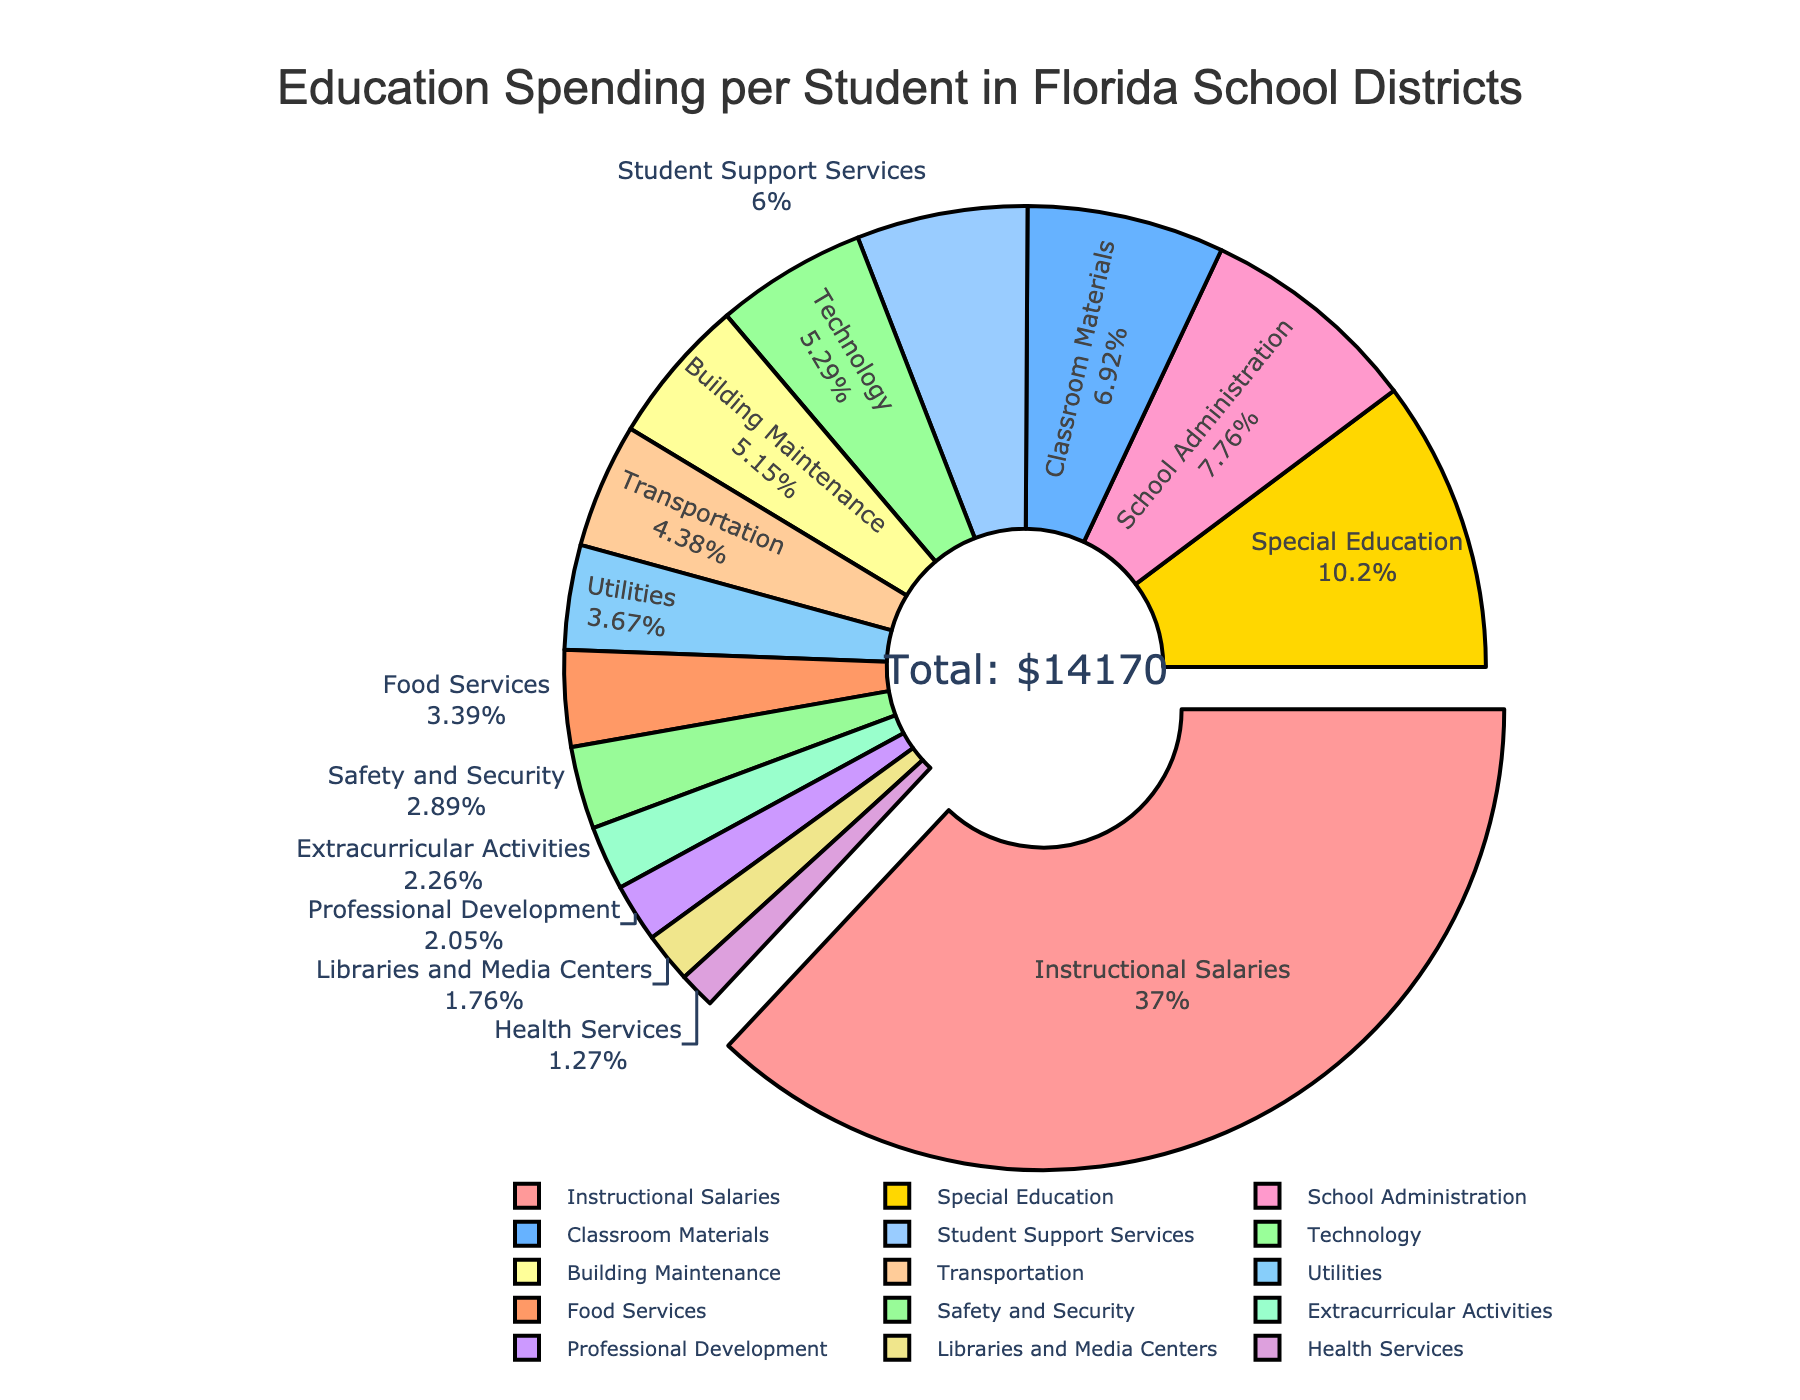What's the largest category of spending? To determine the largest category of spending, locate the segment of the pie chart that is pulled out. The segment for 'Instructional Salaries' is pulled out, indicating it is the largest category.
Answer: Instructional Salaries Which category has the smallest percentage of spending? To find the smallest percentage, look for the smallest segment in the pie chart. The segment labeled 'Professional Development' is the smallest, indicating it has the smallest percentage.
Answer: Professional Development How much more is spent on Instructional Salaries compared to Technology? Instructional Salaries category amount is $5240. Technology category amount is $750. The difference is $5240 - $750 = $4490.
Answer: $4490 Which category receives less funding: Transportation or Building Maintenance? On the pie chart, compare the segments for 'Transportation' and 'Building Maintenance'. Transportation has $620 and Building Maintenance has $730. Transportation receives less funding.
Answer: Transportation What is the combined spending on Special Education and Student Support Services? Add the amounts for the categories: Special Education ($1450) + Student Support Services ($850). The total is $1450 + $850 = $2300.
Answer: $2300 Is the spending on School Administration greater than the combined spending on Technology and Classroom Materials? Compare School Administration ($1100) with the sum of Technology ($750) and Classroom Materials ($980). Sum is $750 + $980 = $1730. Since $1100 is less than $1730, the spending on School Administration is not greater.
Answer: No How much more is spent on Safety and Security compared to Health Services? Safety and Security spending is $410, and Health Services spending is $180. The difference is $410 - $180 = $230.
Answer: $230 Which three categories have the largest spending and what are their respective percentages? Identify the three largest segments which are Instructional Salaries ($5240), Special Education ($1450), and School Administration ($1100). Calculate their percentages of the total sum of $13320: Instructional Salaries: ($5240/$13320) x 100 = 39.3%, Special Education: ($1450/$13320) x 100 = 10.9%, School Administration: ($1100/$13320) x 100 = 8.3%.
Answer: Instructional Salaries (39.3%), Special Education (10.9%), School Administration (8.3%) What's the approximate total spending on categories related to student activities including Extracurricular Activities and Classroom Materials? Add the amounts for both categories: Extracurricular Activities ($320) + Classroom Materials ($980). The total spending is $320 + $980 = $1300.
Answer: $1300 How does spending on School Administration compare to the pooled spending on Technology and Transportation? Sum the amounts for Technology ($750) and Transportation ($620) for a total of $1370. Compare this to School Administration ($1100). $1100 (School Administration) is less than $1370 (Technology + Transportation).
Answer: Less 